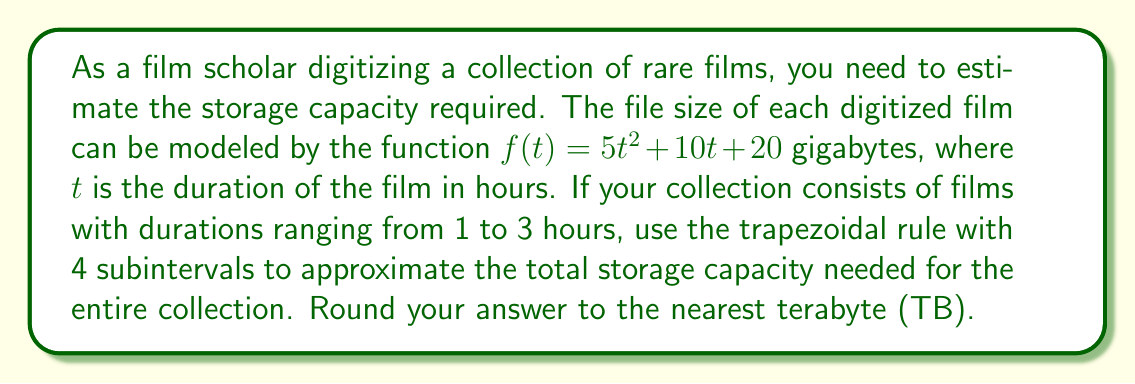Help me with this question. To solve this problem, we'll use the trapezoidal rule for numerical integration. The steps are as follows:

1) The integral we need to approximate is:

   $$\int_1^3 (5t^2 + 10t + 20) dt$$

2) For the trapezoidal rule with 4 subintervals, we need to divide the interval [1, 3] into 4 equal parts:

   $\Delta t = \frac{3-1}{4} = 0.5$

3) The points are: $t_0 = 1$, $t_1 = 1.5$, $t_2 = 2$, $t_3 = 2.5$, $t_4 = 3$

4) Now we calculate $f(t)$ for each of these points:

   $f(1) = 5(1)^2 + 10(1) + 20 = 35$
   $f(1.5) = 5(1.5)^2 + 10(1.5) + 20 = 53.75$
   $f(2) = 5(2)^2 + 10(2) + 20 = 80$
   $f(2.5) = 5(2.5)^2 + 10(2.5) + 20 = 113.75$
   $f(3) = 5(3)^2 + 10(3) + 20 = 155$

5) The trapezoidal rule formula is:

   $$\int_a^b f(x)dx \approx \frac{\Delta x}{2}[f(x_0) + 2f(x_1) + 2f(x_2) + ... + 2f(x_{n-1}) + f(x_n)]$$

6) Plugging in our values:

   $$\int_1^3 f(t)dt \approx \frac{0.5}{2}[35 + 2(53.75) + 2(80) + 2(113.75) + 155]$$
   $$= 0.25[35 + 107.5 + 160 + 227.5 + 155]$$
   $$= 0.25[685] = 171.25$$

7) This result is in gigabytes. To convert to terabytes, we divide by 1000:

   $171.25 \text{ GB} = 0.17125 \text{ TB}$

8) Rounding to the nearest terabyte:

   $0.17125 \text{ TB} \approx 0 \text{ TB}$
Answer: 0 TB 